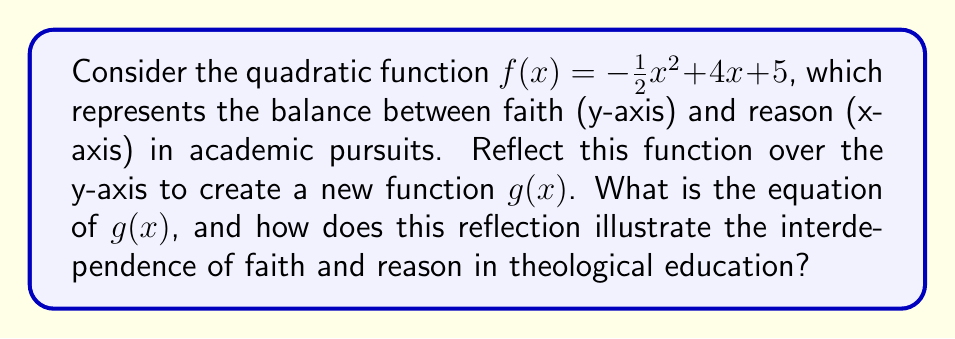Can you answer this question? To reflect the function $f(x) = -\frac{1}{2}x^2 + 4x + 5$ over the y-axis, we need to replace every $x$ with $-x$ in the original function. This gives us:

$g(x) = -\frac{1}{2}(-x)^2 + 4(-x) + 5$

Simplifying:
1. $(-x)^2 = x^2$, so the first term remains $-\frac{1}{2}x^2$
2. $4(-x) = -4x$
3. The constant term 5 remains unchanged

Therefore, $g(x) = -\frac{1}{2}x^2 - 4x + 5$

This reflection illustrates the interdependence of faith and reason in theological education:

1. The parabola opens downward in both $f(x)$ and $g(x)$, suggesting that extremes in either faith or reason may lead to diminishing returns in academic pursuits.

2. The vertex of $f(x)$ is on the positive x-axis, while the vertex of $g(x)$ is on the negative x-axis. This symmetry represents the balance between faith and reason, showing that both are essential in theological studies.

3. The y-intercept (5) remains the same for both functions, indicating a common starting point or foundation in theological education, regardless of the approach.

4. The reflection demonstrates that an overemphasis on either faith or reason (moving too far along the x-axis in either direction) results in similar outcomes, highlighting the importance of maintaining a balance between the two in academic pursuits.

[asy]
import graph;
size(200);
real f(real x) {return -0.5*x^2 + 4*x + 5;}
real g(real x) {return -0.5*x^2 - 4*x + 5;}
xaxis("Reason", arrow=Arrow);
yaxis("Faith", arrow=Arrow);
draw(graph(f,-2,10), blue);
draw(graph(g,-10,2), red);
label("f(x)", (6,f(6)), E, blue);
label("g(x)", (-6,g(-6)), W, red);
[/asy]
Answer: The equation of $g(x)$ is $g(x) = -\frac{1}{2}x^2 - 4x + 5$. This reflection illustrates the interdependence of faith and reason in theological education by showing symmetry between the two approaches, emphasizing the importance of balance, and demonstrating that extremes in either direction may lead to diminishing returns in academic pursuits. 